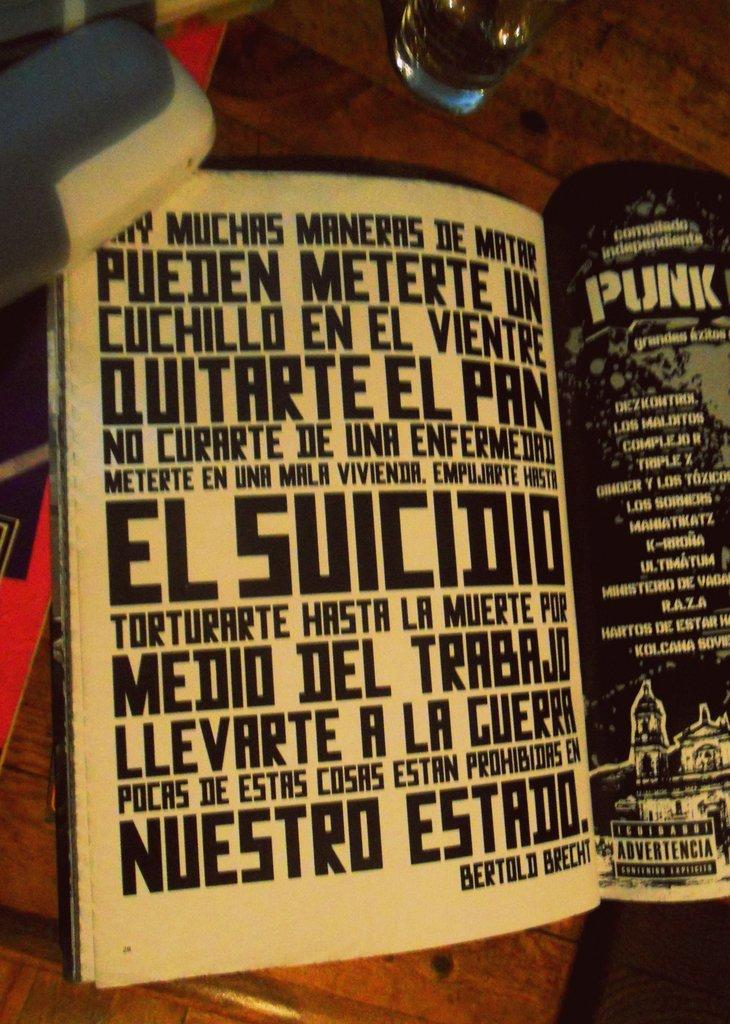<image>
Share a concise interpretation of the image provided. a magazine is open on a table to a page that says punk 